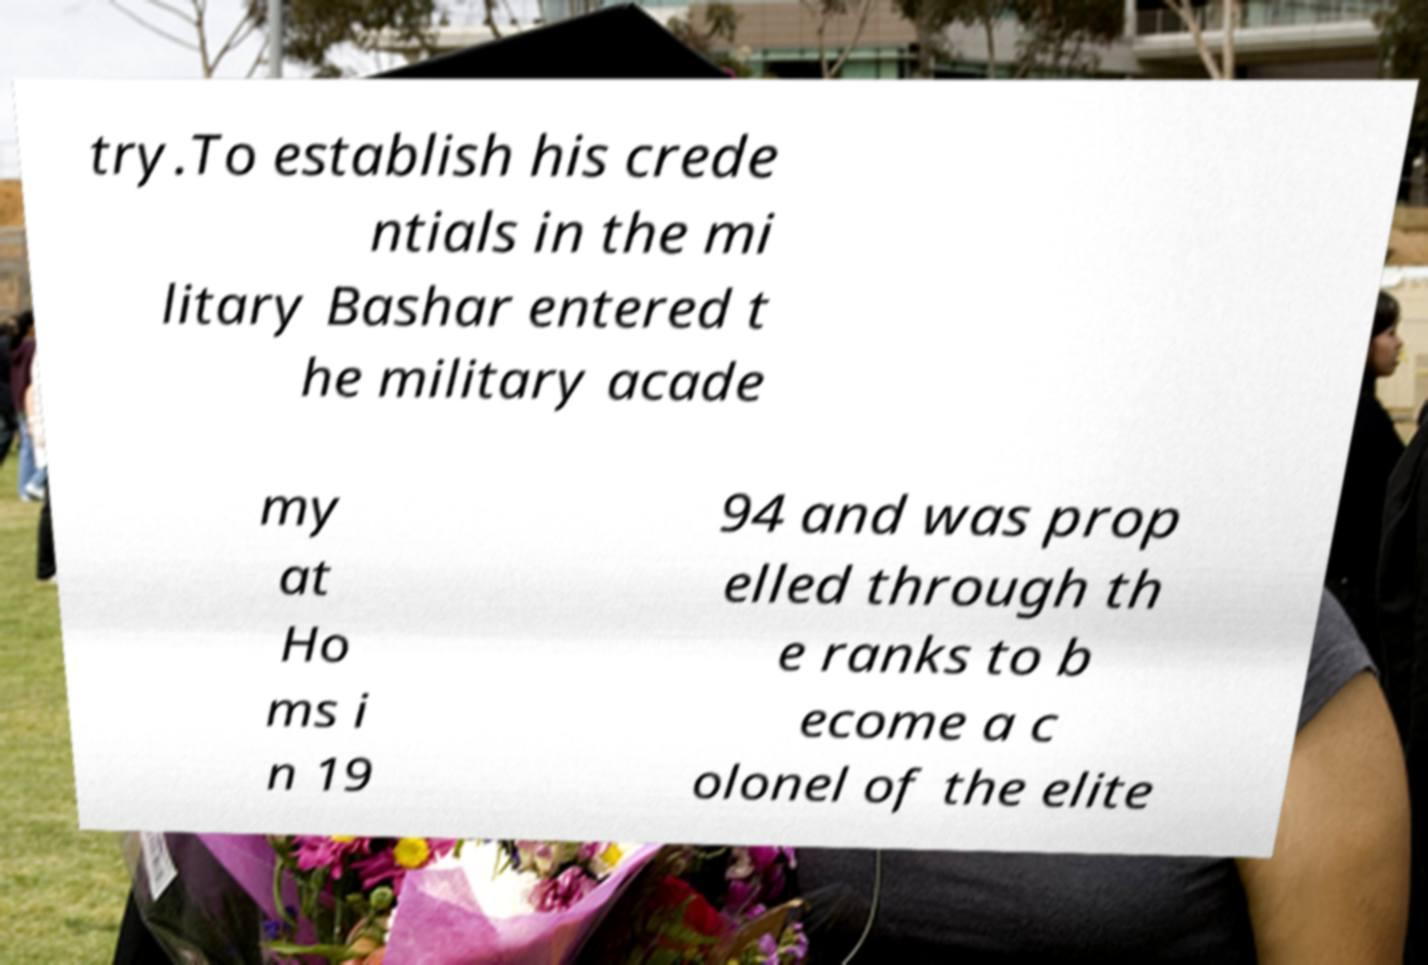Can you accurately transcribe the text from the provided image for me? try.To establish his crede ntials in the mi litary Bashar entered t he military acade my at Ho ms i n 19 94 and was prop elled through th e ranks to b ecome a c olonel of the elite 